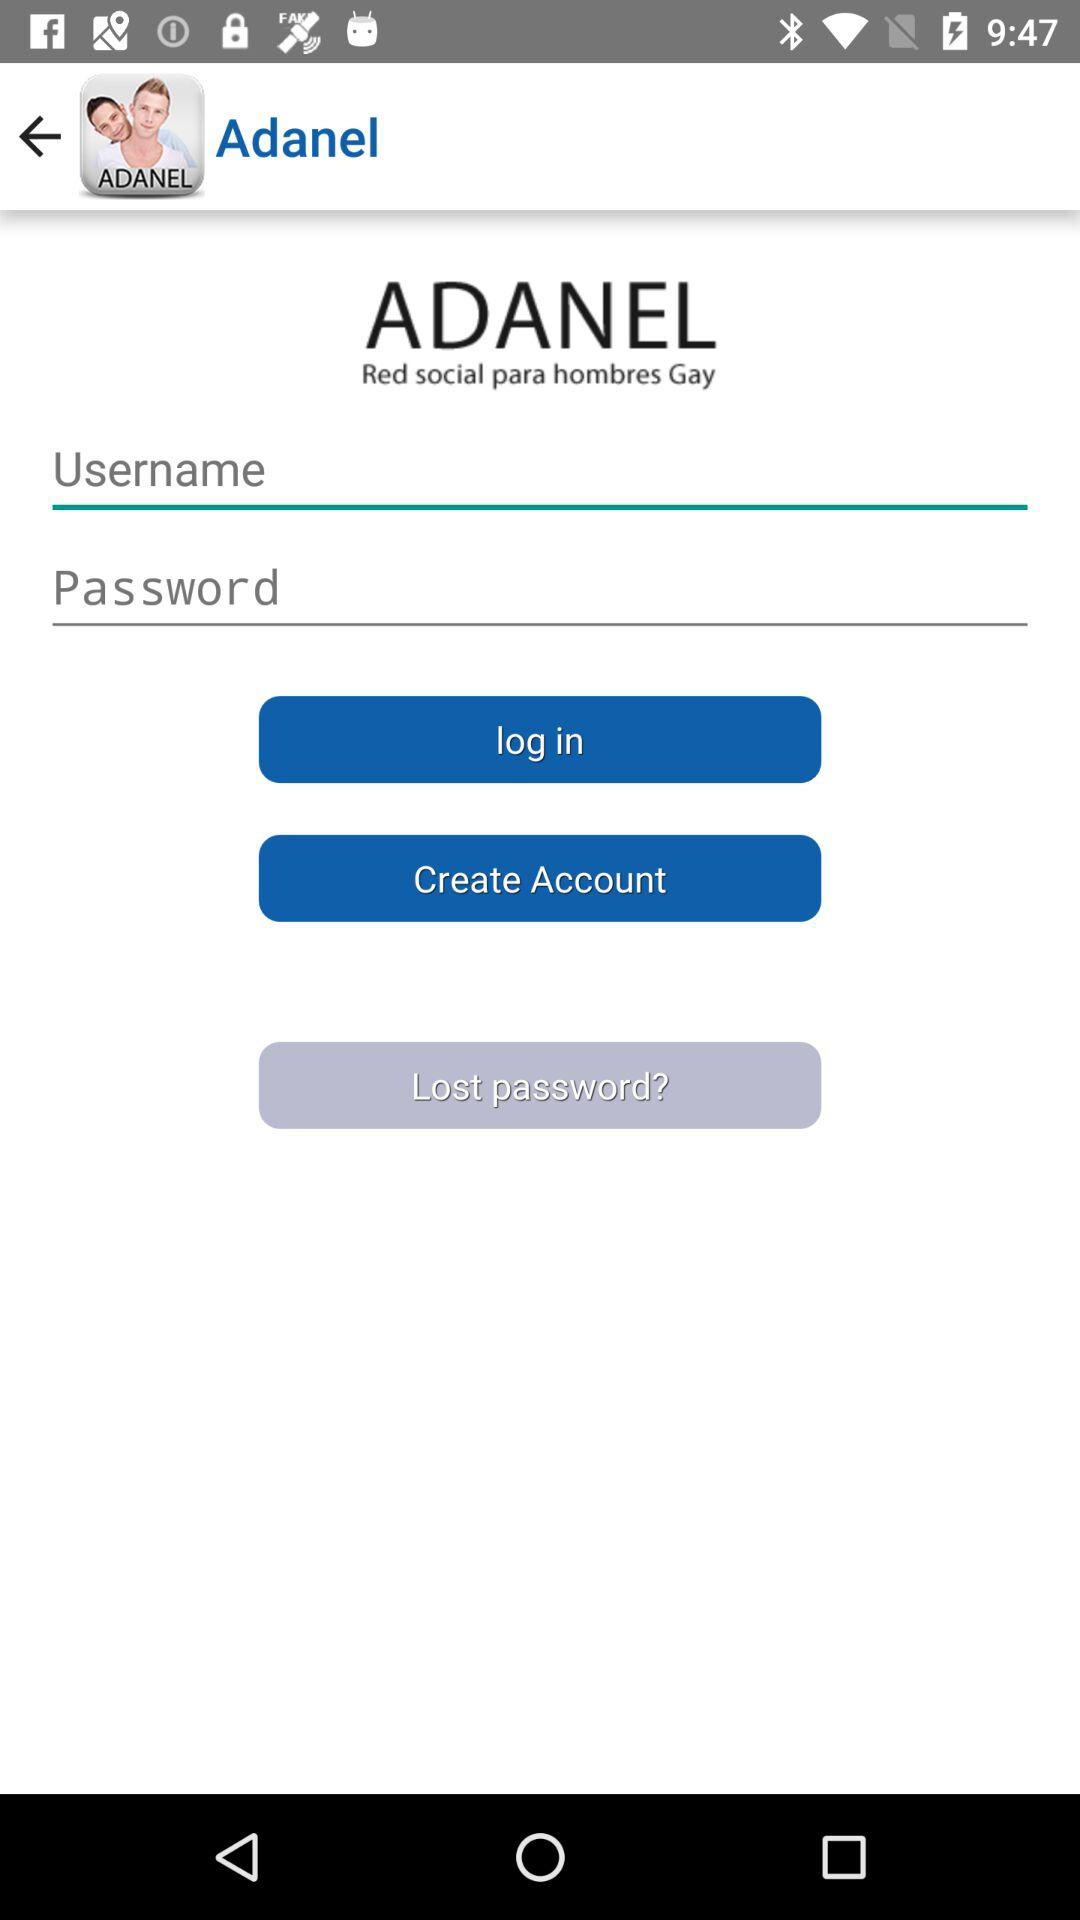How many text fields are there in the login form?
Answer the question using a single word or phrase. 2 